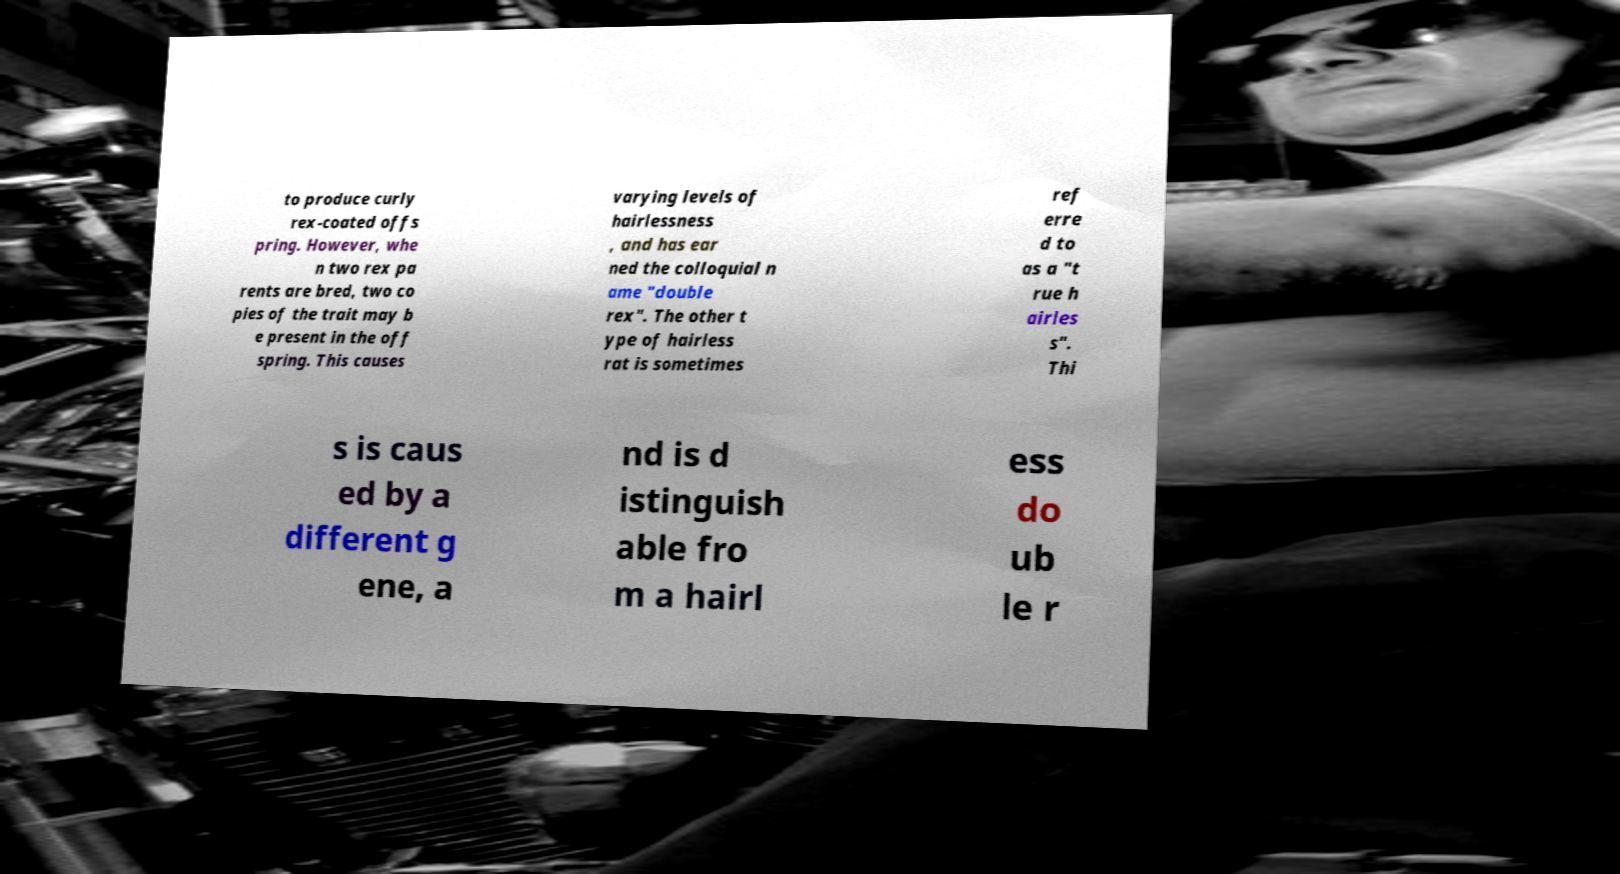What messages or text are displayed in this image? I need them in a readable, typed format. to produce curly rex-coated offs pring. However, whe n two rex pa rents are bred, two co pies of the trait may b e present in the off spring. This causes varying levels of hairlessness , and has ear ned the colloquial n ame "double rex". The other t ype of hairless rat is sometimes ref erre d to as a "t rue h airles s". Thi s is caus ed by a different g ene, a nd is d istinguish able fro m a hairl ess do ub le r 